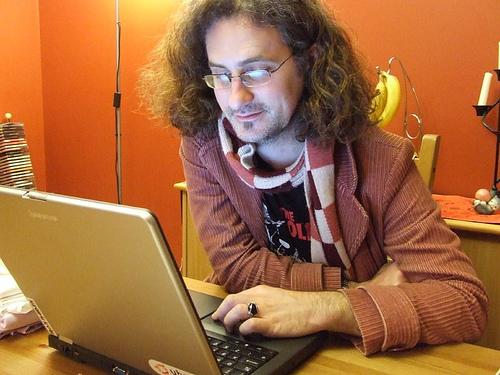Where is the laptop?
Answer briefly. Table. What is the man looking at?
Concise answer only. Laptop. What is hanging in the background?
Be succinct. Bananas. 